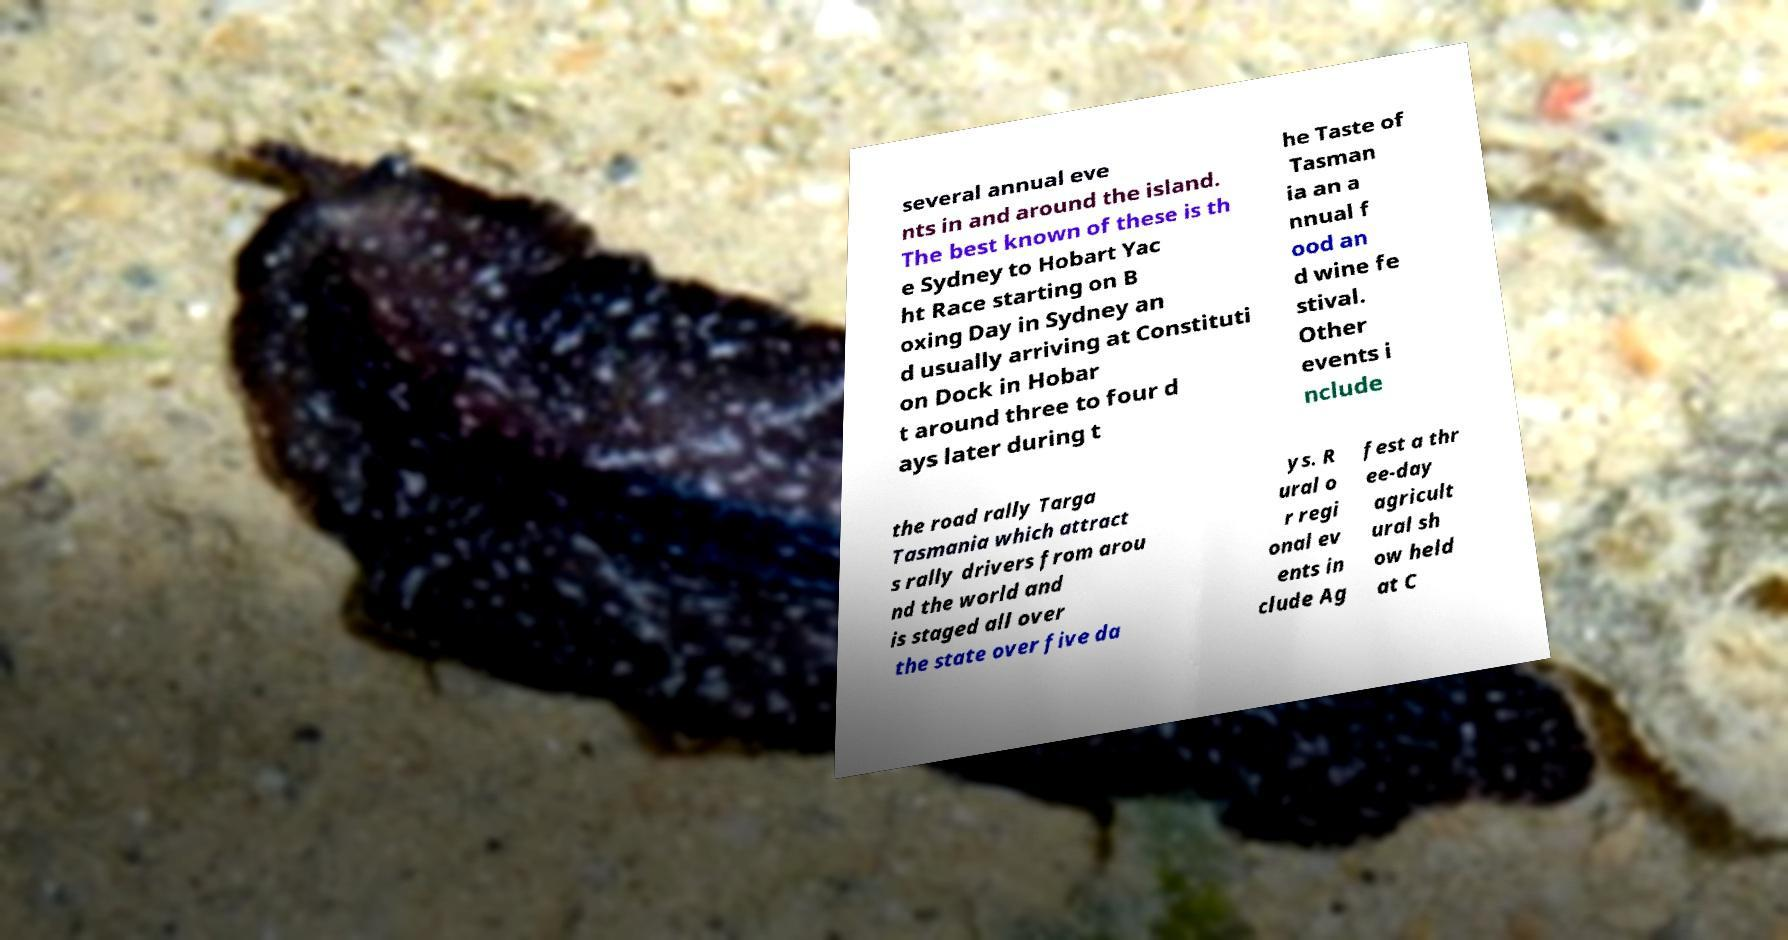Please read and relay the text visible in this image. What does it say? several annual eve nts in and around the island. The best known of these is th e Sydney to Hobart Yac ht Race starting on B oxing Day in Sydney an d usually arriving at Constituti on Dock in Hobar t around three to four d ays later during t he Taste of Tasman ia an a nnual f ood an d wine fe stival. Other events i nclude the road rally Targa Tasmania which attract s rally drivers from arou nd the world and is staged all over the state over five da ys. R ural o r regi onal ev ents in clude Ag fest a thr ee-day agricult ural sh ow held at C 